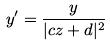Convert formula to latex. <formula><loc_0><loc_0><loc_500><loc_500>y ^ { \prime } = \frac { y } { | c z + d | ^ { 2 } }</formula> 